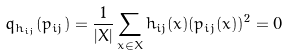<formula> <loc_0><loc_0><loc_500><loc_500>q _ { h _ { i j } } ( p _ { i j } ) = \frac { 1 } { | X | } \sum _ { x \in X } h _ { i j } ( x ) ( p _ { i j } ( x ) ) ^ { 2 } = 0</formula> 